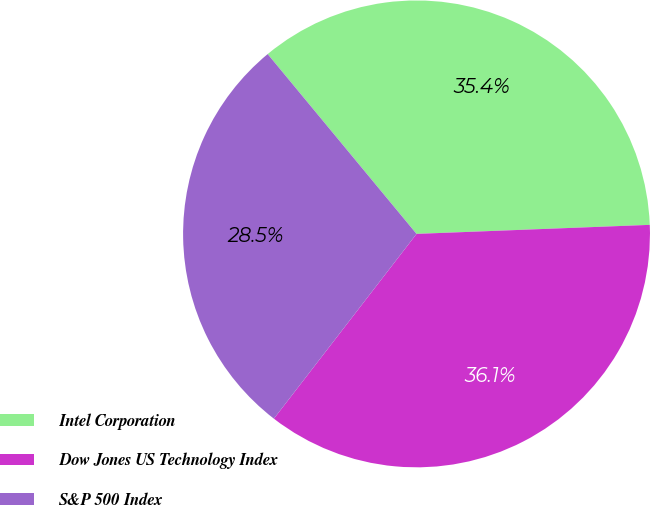<chart> <loc_0><loc_0><loc_500><loc_500><pie_chart><fcel>Intel Corporation<fcel>Dow Jones US Technology Index<fcel>S&P 500 Index<nl><fcel>35.39%<fcel>36.08%<fcel>28.53%<nl></chart> 